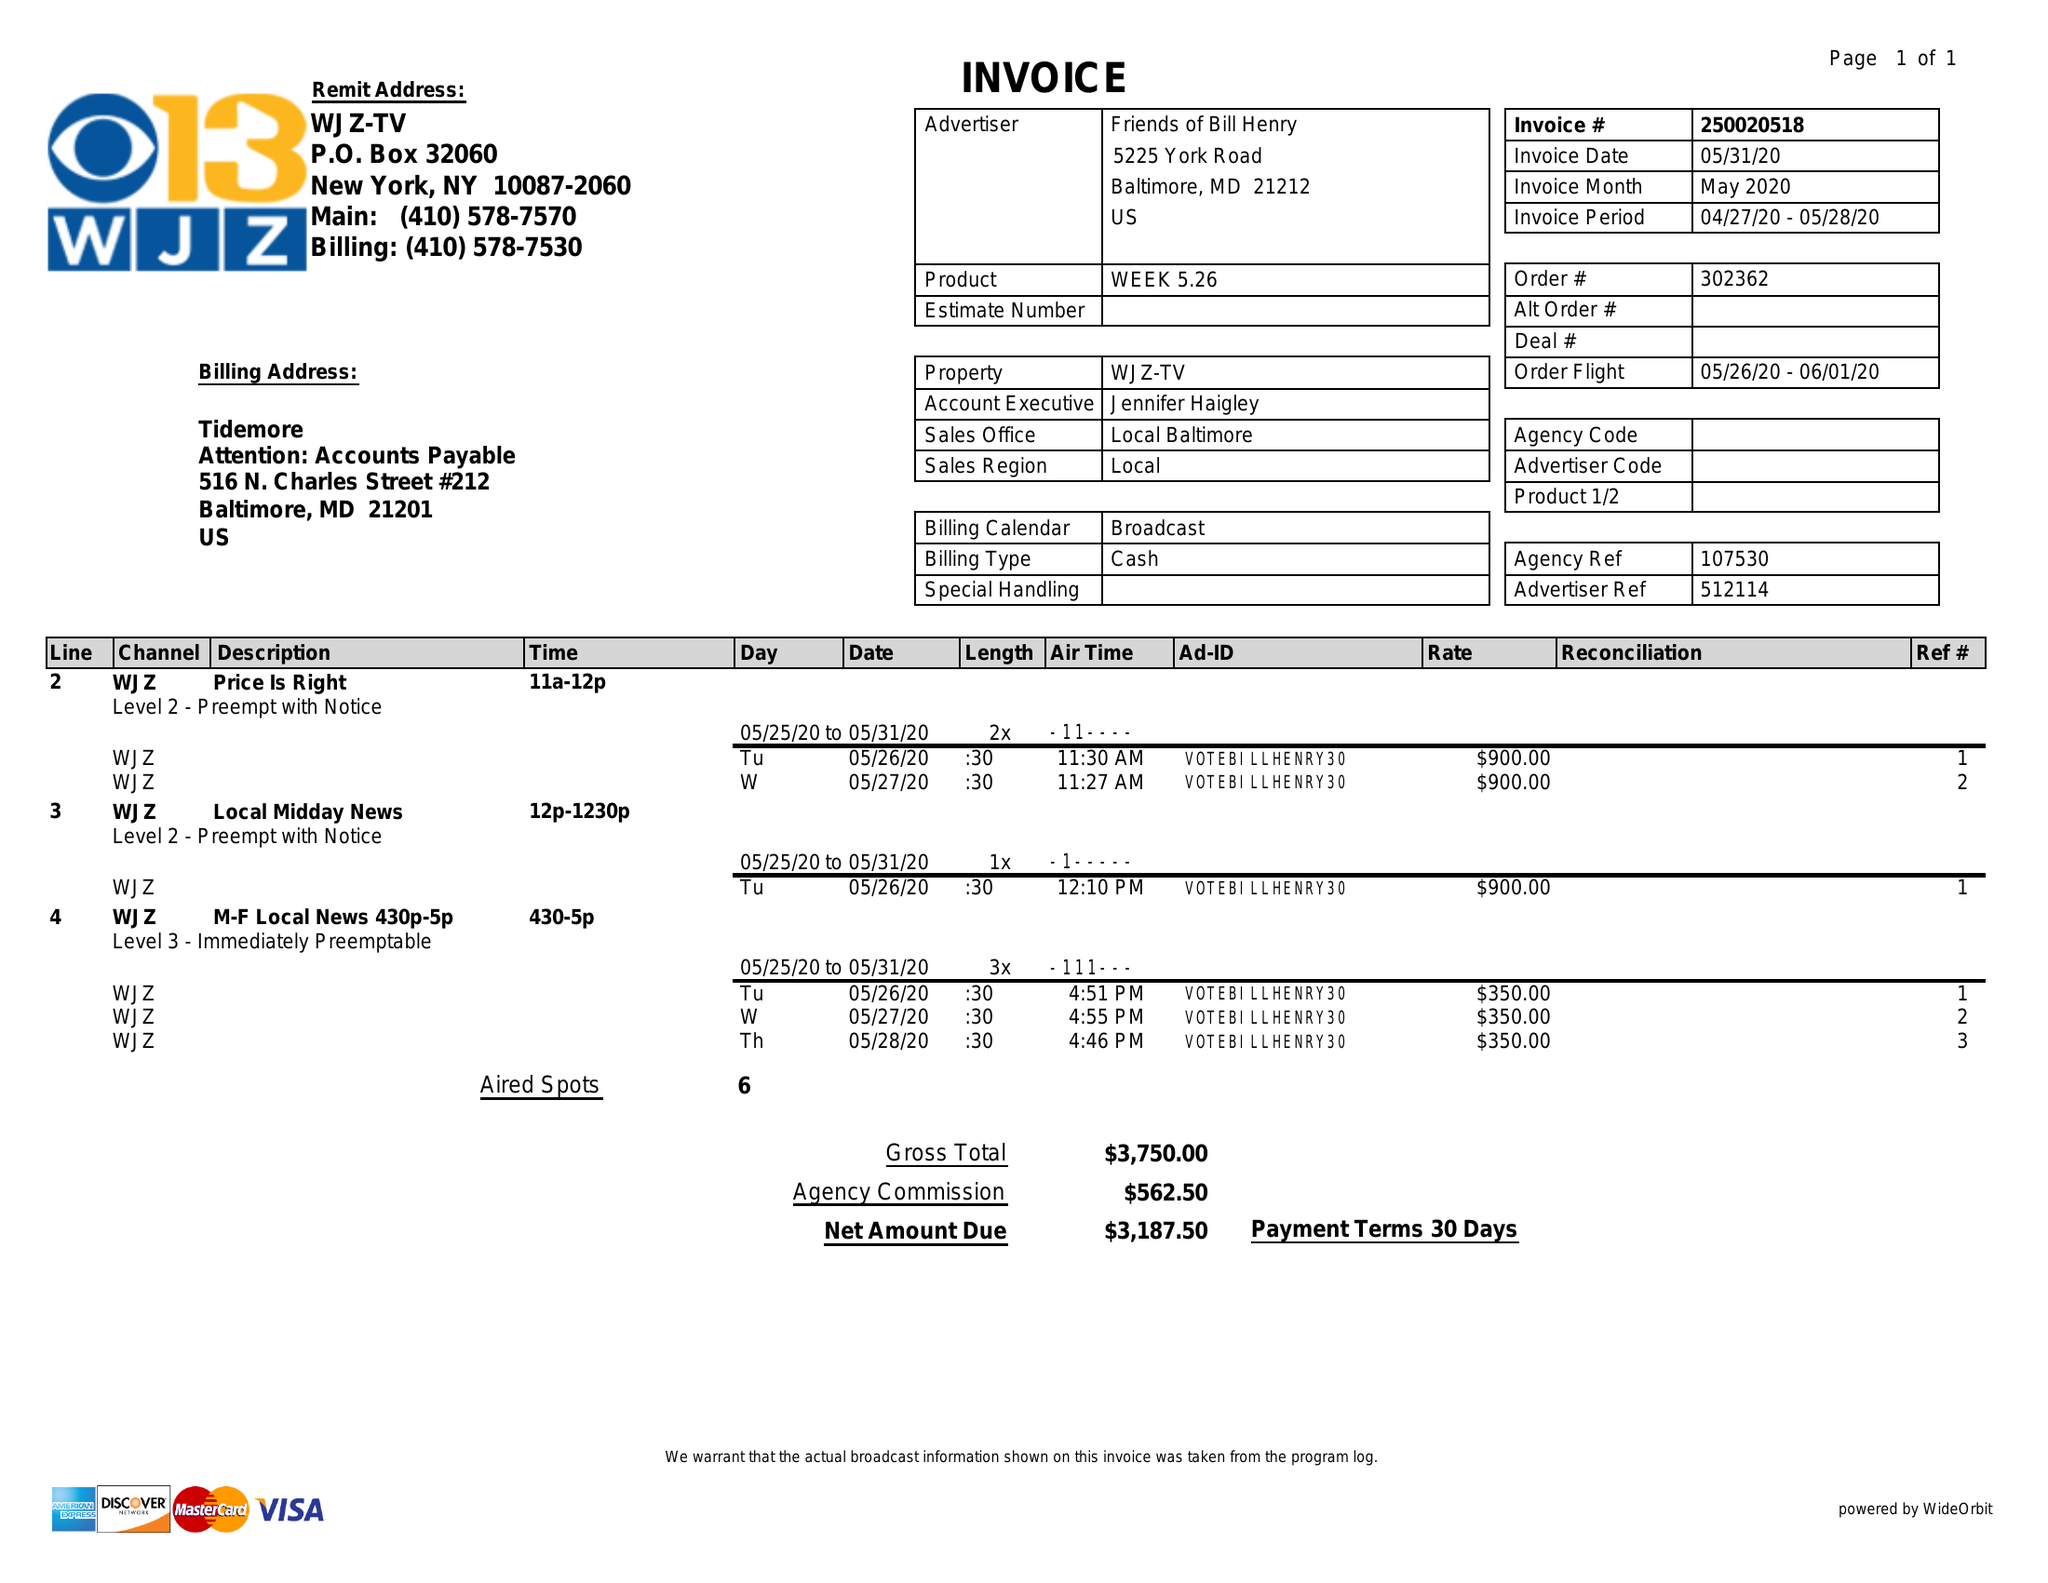What is the value for the flight_to?
Answer the question using a single word or phrase. 06/01/20 